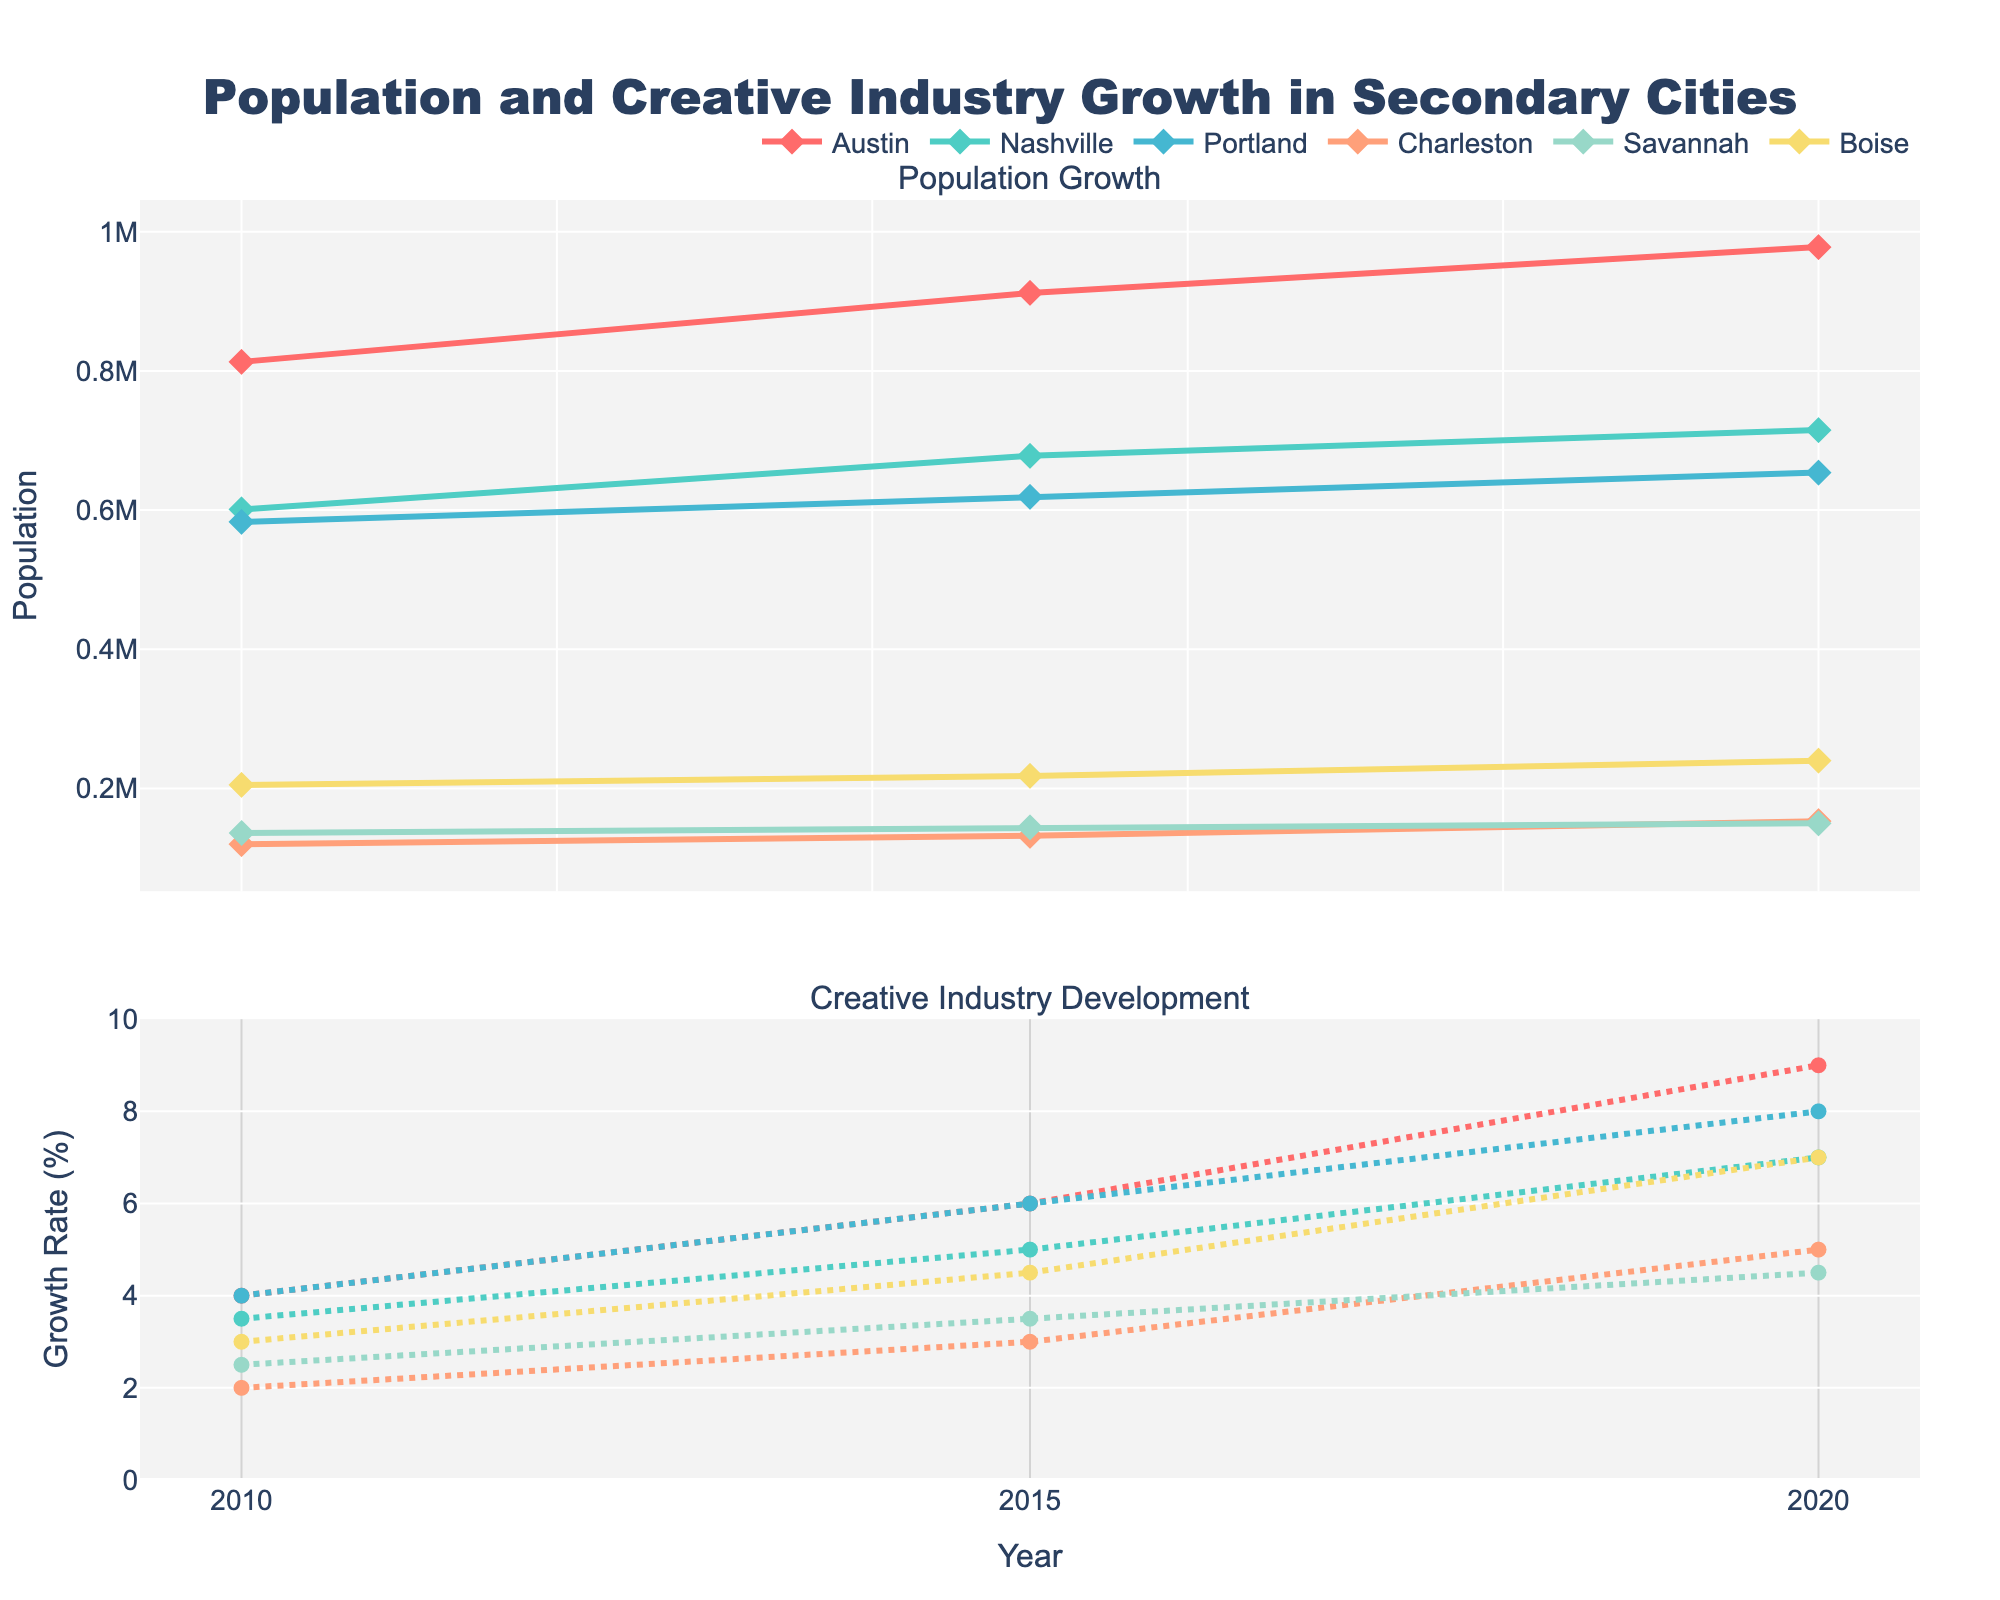How has the population of Austin changed from 2010 to 2020? Look at the population data for Austin in 2010, 2015, and 2020. You can see the population increased from 813,000 in 2010 to 978,000 in 2020.
Answer: Increased from 813,000 to 978,000 Which city had the highest creative industry growth in 2020? Check the Creative Industry Growth data for each city in 2020. Austin has the highest growth rate at 9%, according to the second subplot.
Answer: Austin What is the difference in the number of creative industry opportunities between Nashville and Boise in 2020? First, find the number of opportunities for both cities in 2020: Nashville has 160 and Boise has 130. The difference is 160 - 130.
Answer: 30 Which city had a faster population growth between 2015 and 2020, Portland or Boise? Compare the population increase for Portland (654,000 - 619,000) = 35,000 and Boise (240,000 - 218,000) = 22,000 between 2015 and 2020. Hence, Portland had a faster growth.
Answer: Portland From 2010 to 2015, which city showed the greatest increase in creative industry growth rate? Calculate the increase for each city: Austin (6-4)=2, Nashville (5-3.5)=1.5, Portland (6-4)=2, Charleston (3-2)=1, Savannah (3.5-2.5)=1, Boise (4.5-3)=1.5. Austin and Portland have the greatest increase at 2%.
Answer: Austin and Portland How many cities had a population exceeding 700,000 in 2020? Verify the population figure for each city in 2020: Austin (978,000), Nashville (715,000), Portland (654,000), Charleston (153,000), Savannah (150,000), Boise (240,000). Only Austin and Nashville exceed 700,000.
Answer: 2 Comparing the creative industry growth rate between Austin and Charleston in 2010 and 2020, how much did each city's growth rate change over the decade? For Austin: 2010 (4) to 2020 (9), change = 9 - 4 = 5. For Charleston: 2010 (2) to 2020 (5), change = 5 - 2 = 3.
Answer: Austin: 5, Charleston: 3 Which city had the least number of creative industry opportunities in 2015? Check the 2015 opportunities for all cities: Austin (145), Nashville (130), Portland (140), Charleston (50), Savannah (60), Boise (75). Charleston had the least opportunities.
Answer: Charleston 